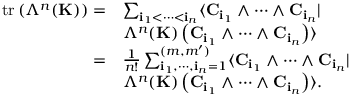Convert formula to latex. <formula><loc_0><loc_0><loc_500><loc_500>\begin{array} { r l } { t r \left ( \Lambda ^ { n } ( { K } ) \right ) = } & { \sum _ { { i } _ { 1 } < \cdots < { i } _ { n } } \langle { C } _ { { i } _ { 1 } } \wedge \cdots \wedge { C } _ { { i } _ { n } } | } \\ & { \Lambda ^ { n } ( { K } ) \left ( { C } _ { { i } _ { 1 } } \wedge \cdots \wedge { C } _ { { i } _ { n } } \right ) \rangle } \\ { = } & { \frac { 1 } { n ! } \sum _ { { i } _ { 1 } , \cdots , { i } _ { n } = 1 } ^ { ( m , m ^ { \prime } ) } \langle { C } _ { { i } _ { 1 } } \wedge \cdots \wedge { C } _ { { i } _ { n } } | } \\ & { \Lambda ^ { n } ( { K } ) \left ( { C } _ { { i } _ { 1 } } \wedge \cdots \wedge { C } _ { { i } _ { n } } \right ) \rangle . } \end{array}</formula> 